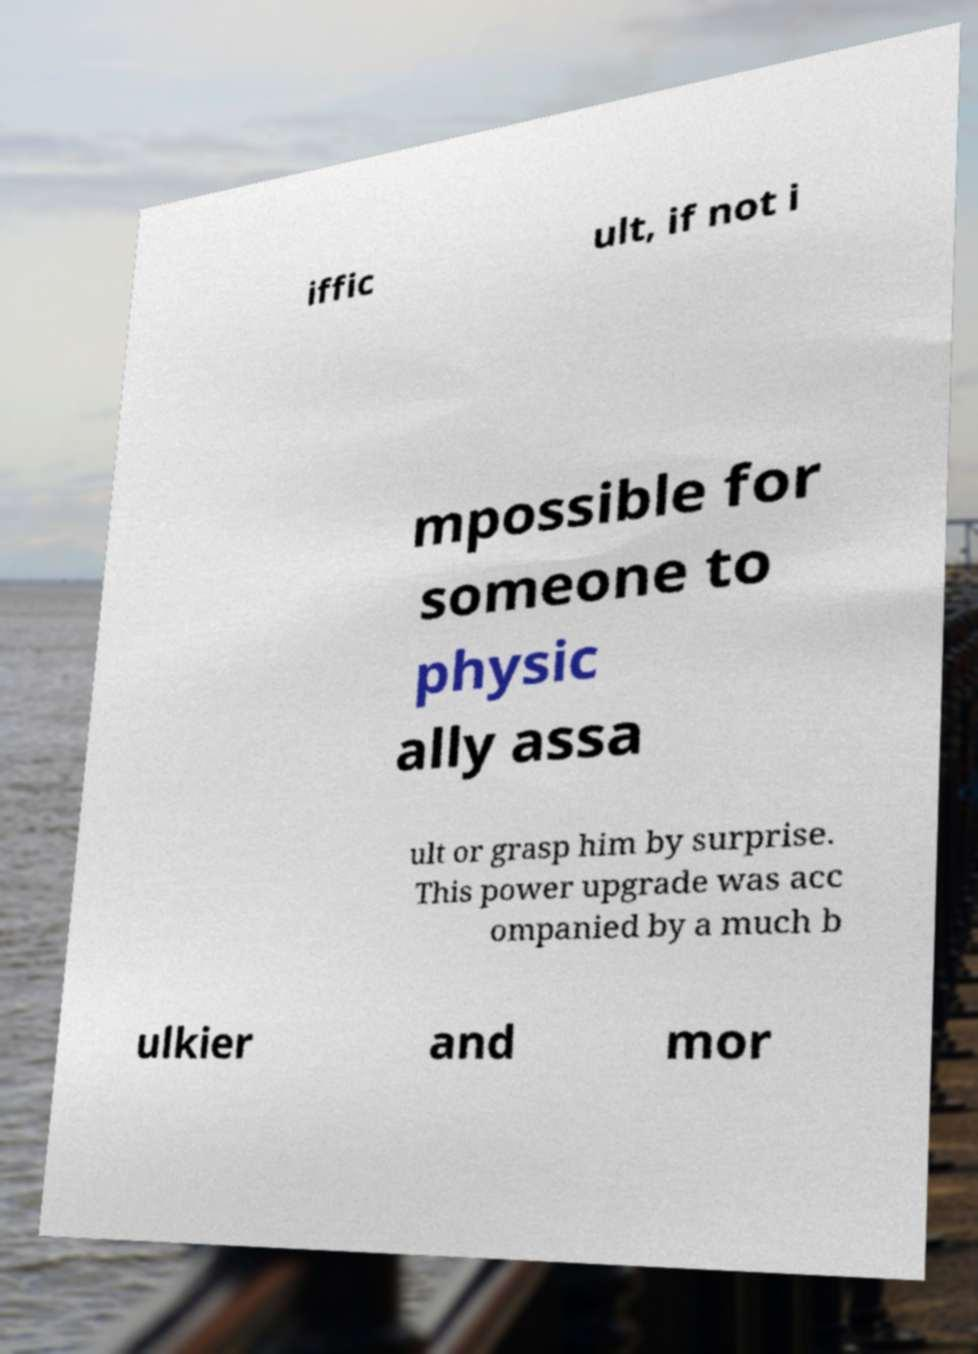For documentation purposes, I need the text within this image transcribed. Could you provide that? iffic ult, if not i mpossible for someone to physic ally assa ult or grasp him by surprise. This power upgrade was acc ompanied by a much b ulkier and mor 